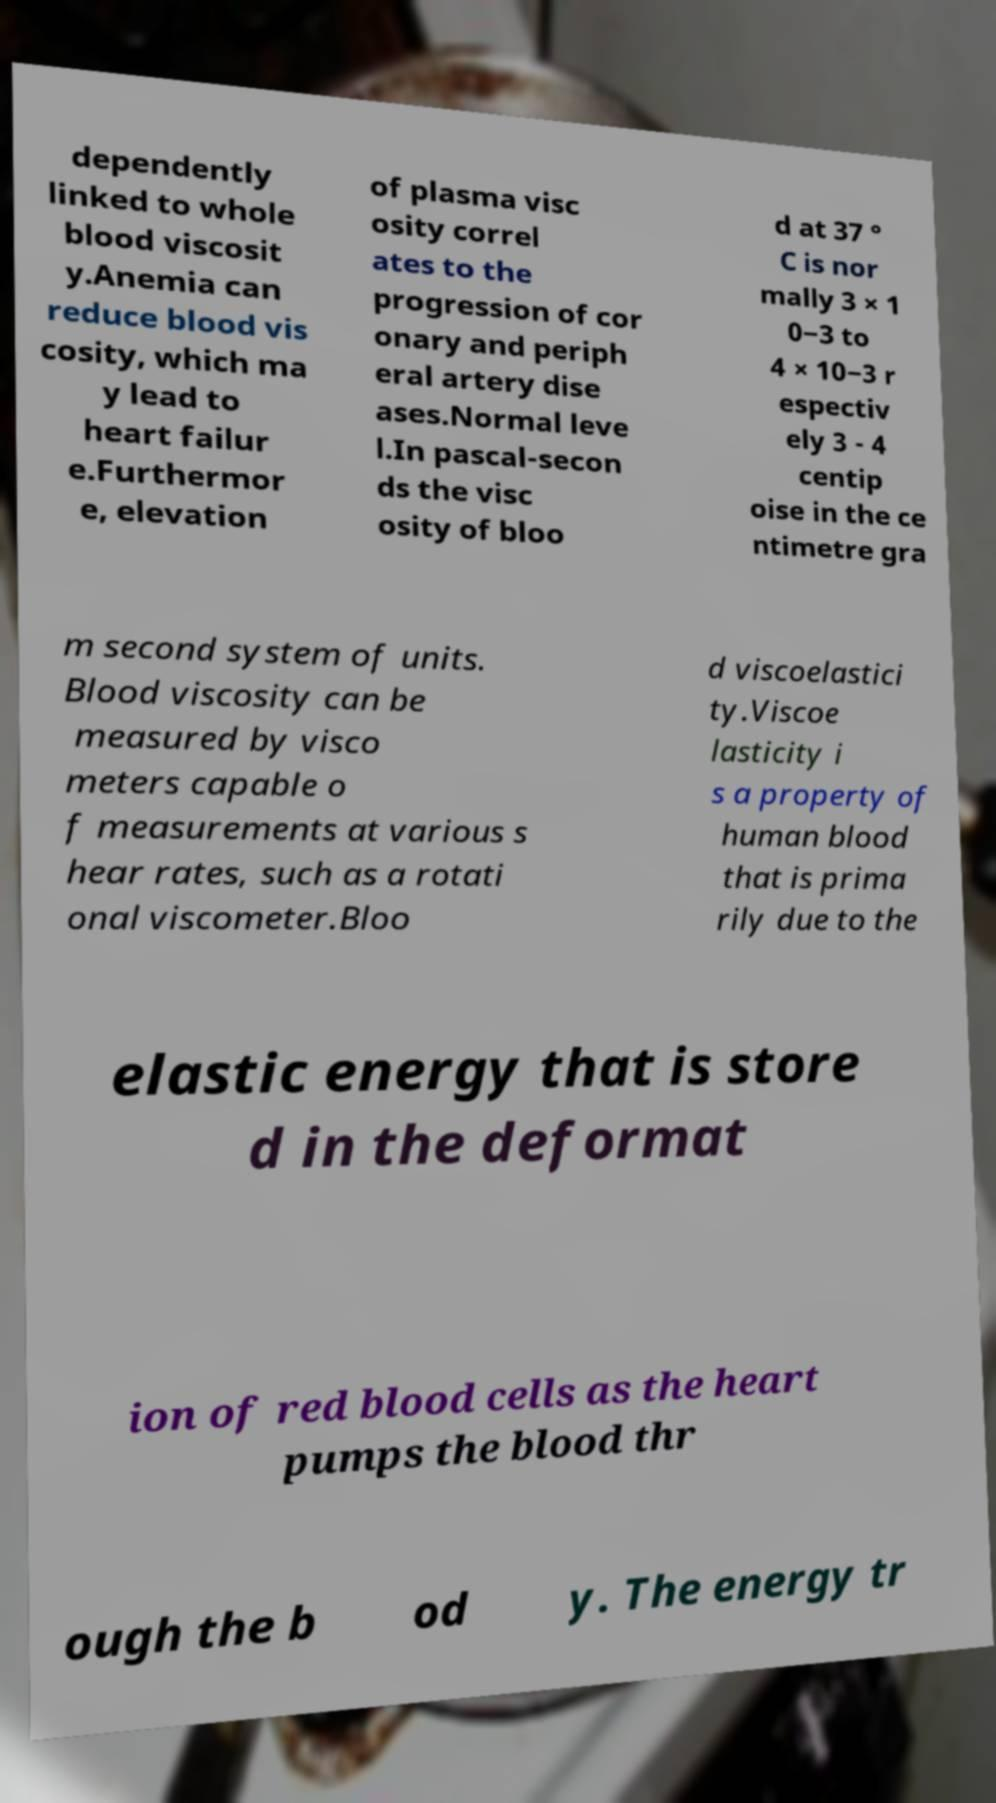What messages or text are displayed in this image? I need them in a readable, typed format. dependently linked to whole blood viscosit y.Anemia can reduce blood vis cosity, which ma y lead to heart failur e.Furthermor e, elevation of plasma visc osity correl ates to the progression of cor onary and periph eral artery dise ases.Normal leve l.In pascal-secon ds the visc osity of bloo d at 37 ° C is nor mally 3 × 1 0−3 to 4 × 10−3 r espectiv ely 3 - 4 centip oise in the ce ntimetre gra m second system of units. Blood viscosity can be measured by visco meters capable o f measurements at various s hear rates, such as a rotati onal viscometer.Bloo d viscoelastici ty.Viscoe lasticity i s a property of human blood that is prima rily due to the elastic energy that is store d in the deformat ion of red blood cells as the heart pumps the blood thr ough the b od y. The energy tr 